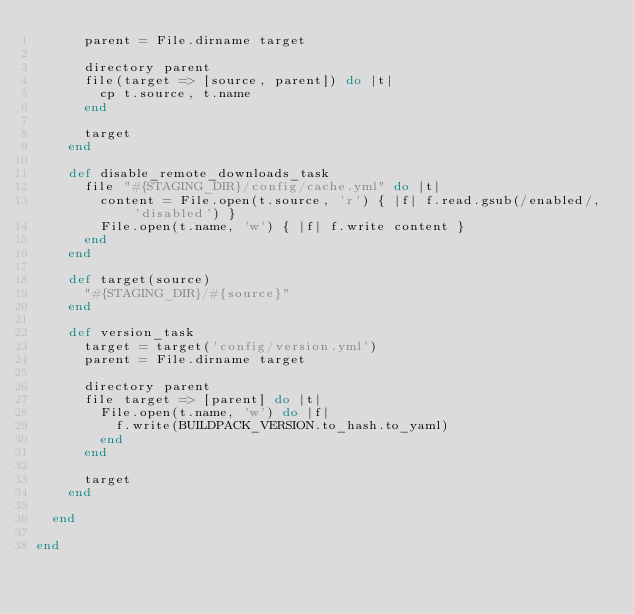Convert code to text. <code><loc_0><loc_0><loc_500><loc_500><_Ruby_>      parent = File.dirname target

      directory parent
      file(target => [source, parent]) do |t|
        cp t.source, t.name
      end

      target
    end

    def disable_remote_downloads_task
      file "#{STAGING_DIR}/config/cache.yml" do |t|
        content = File.open(t.source, 'r') { |f| f.read.gsub(/enabled/, 'disabled') }
        File.open(t.name, 'w') { |f| f.write content }
      end
    end

    def target(source)
      "#{STAGING_DIR}/#{source}"
    end

    def version_task
      target = target('config/version.yml')
      parent = File.dirname target

      directory parent
      file target => [parent] do |t|
        File.open(t.name, 'w') do |f|
          f.write(BUILDPACK_VERSION.to_hash.to_yaml)
        end
      end

      target
    end

  end

end
</code> 